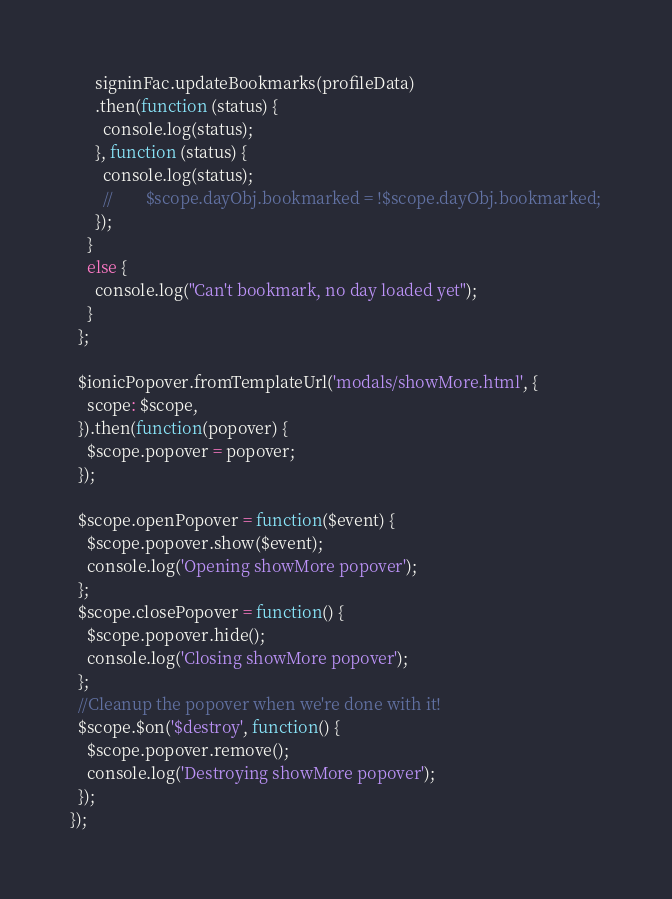<code> <loc_0><loc_0><loc_500><loc_500><_JavaScript_>      signinFac.updateBookmarks(profileData)
      .then(function (status) {
        console.log(status);
      }, function (status) {
        console.log(status);
        //        $scope.dayObj.bookmarked = !$scope.dayObj.bookmarked;
      });
    }
    else {
      console.log("Can't bookmark, no day loaded yet");
    }
  };

  $ionicPopover.fromTemplateUrl('modals/showMore.html', {
    scope: $scope,
  }).then(function(popover) {
    $scope.popover = popover;
  });

  $scope.openPopover = function($event) {
    $scope.popover.show($event);
    console.log('Opening showMore popover');
  };
  $scope.closePopover = function() {
    $scope.popover.hide();
    console.log('Closing showMore popover');
  };
  //Cleanup the popover when we're done with it!
  $scope.$on('$destroy', function() {
    $scope.popover.remove();
    console.log('Destroying showMore popover');
  });
});
</code> 